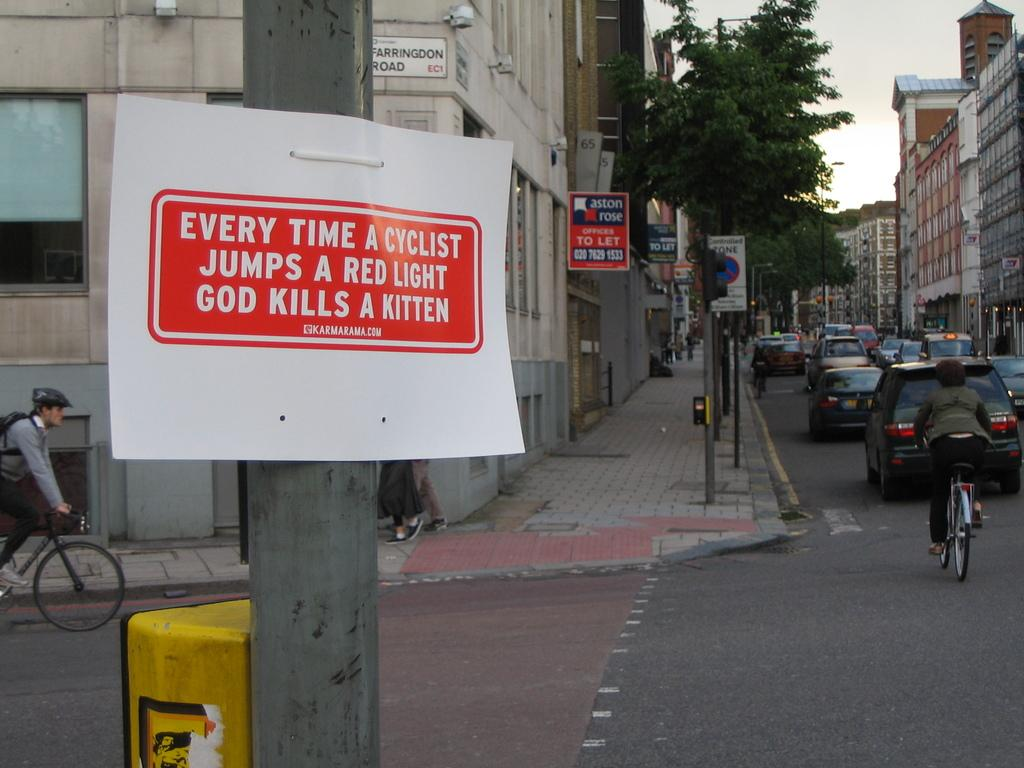<image>
Describe the image concisely. A sign is secured to a street pole that insinuates if cyclist proceed on a red light, a kitten dies. 